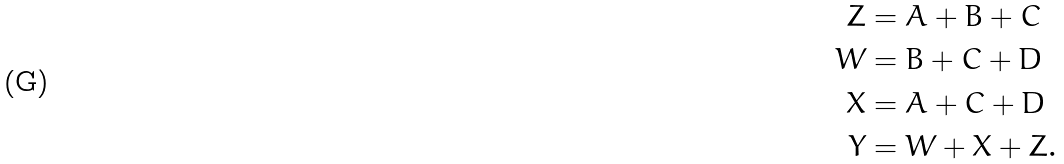Convert formula to latex. <formula><loc_0><loc_0><loc_500><loc_500>Z & = A + B + C \\ W & = B + C + D \\ X & = A + C + D \\ Y & = W + X + Z .</formula> 